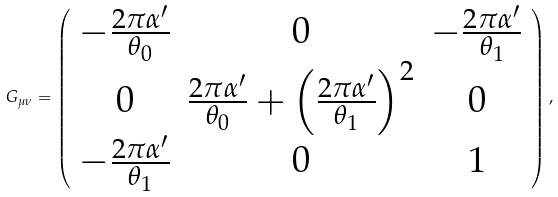Convert formula to latex. <formula><loc_0><loc_0><loc_500><loc_500>G _ { \mu \nu } = \left ( \begin{array} { c c c } { { - \frac { 2 \pi \alpha ^ { \prime } } { \theta _ { 0 } } } } & { 0 } & { { - \frac { 2 \pi \alpha ^ { \prime } } { \theta _ { 1 } } } } \\ { 0 } & { { \frac { 2 \pi \alpha ^ { \prime } } { \theta _ { 0 } } + \left ( \frac { 2 \pi \alpha ^ { \prime } } { \theta _ { 1 } } \right ) ^ { 2 } } } & { 0 } \\ { { - \frac { 2 \pi \alpha ^ { \prime } } { \theta _ { 1 } } } } & { 0 } & { 1 } \end{array} \right ) ,</formula> 